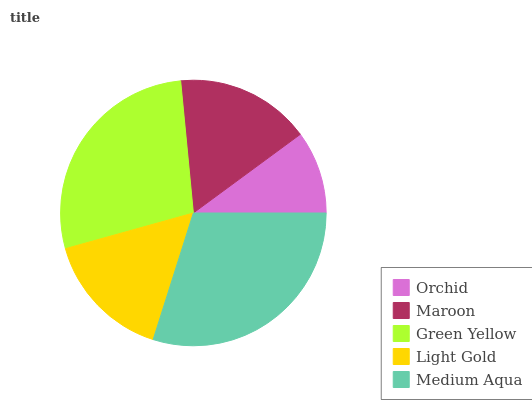Is Orchid the minimum?
Answer yes or no. Yes. Is Medium Aqua the maximum?
Answer yes or no. Yes. Is Maroon the minimum?
Answer yes or no. No. Is Maroon the maximum?
Answer yes or no. No. Is Maroon greater than Orchid?
Answer yes or no. Yes. Is Orchid less than Maroon?
Answer yes or no. Yes. Is Orchid greater than Maroon?
Answer yes or no. No. Is Maroon less than Orchid?
Answer yes or no. No. Is Maroon the high median?
Answer yes or no. Yes. Is Maroon the low median?
Answer yes or no. Yes. Is Orchid the high median?
Answer yes or no. No. Is Orchid the low median?
Answer yes or no. No. 